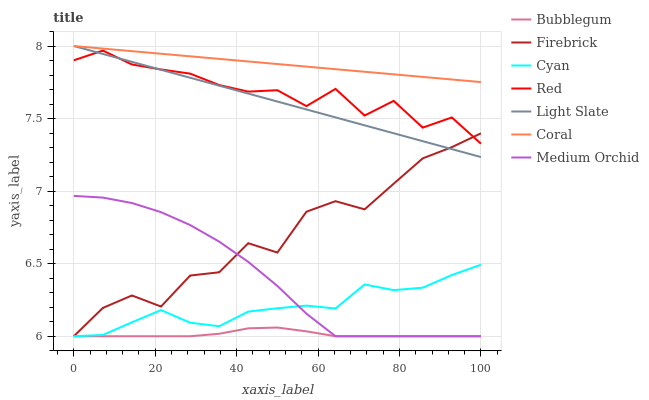Does Bubblegum have the minimum area under the curve?
Answer yes or no. Yes. Does Coral have the maximum area under the curve?
Answer yes or no. Yes. Does Firebrick have the minimum area under the curve?
Answer yes or no. No. Does Firebrick have the maximum area under the curve?
Answer yes or no. No. Is Coral the smoothest?
Answer yes or no. Yes. Is Firebrick the roughest?
Answer yes or no. Yes. Is Medium Orchid the smoothest?
Answer yes or no. No. Is Medium Orchid the roughest?
Answer yes or no. No. Does Firebrick have the lowest value?
Answer yes or no. Yes. Does Coral have the lowest value?
Answer yes or no. No. Does Coral have the highest value?
Answer yes or no. Yes. Does Firebrick have the highest value?
Answer yes or no. No. Is Bubblegum less than Red?
Answer yes or no. Yes. Is Red greater than Cyan?
Answer yes or no. Yes. Does Firebrick intersect Medium Orchid?
Answer yes or no. Yes. Is Firebrick less than Medium Orchid?
Answer yes or no. No. Is Firebrick greater than Medium Orchid?
Answer yes or no. No. Does Bubblegum intersect Red?
Answer yes or no. No. 